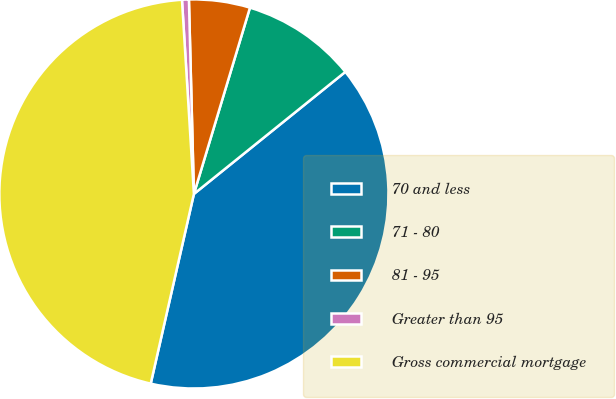Convert chart to OTSL. <chart><loc_0><loc_0><loc_500><loc_500><pie_chart><fcel>70 and less<fcel>71 - 80<fcel>81 - 95<fcel>Greater than 95<fcel>Gross commercial mortgage<nl><fcel>39.36%<fcel>9.55%<fcel>5.06%<fcel>0.57%<fcel>45.46%<nl></chart> 